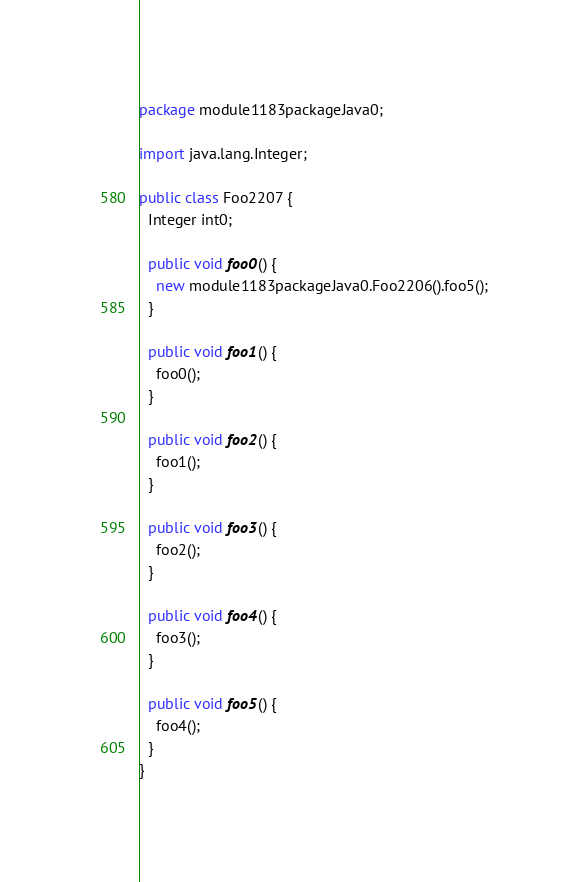<code> <loc_0><loc_0><loc_500><loc_500><_Java_>package module1183packageJava0;

import java.lang.Integer;

public class Foo2207 {
  Integer int0;

  public void foo0() {
    new module1183packageJava0.Foo2206().foo5();
  }

  public void foo1() {
    foo0();
  }

  public void foo2() {
    foo1();
  }

  public void foo3() {
    foo2();
  }

  public void foo4() {
    foo3();
  }

  public void foo5() {
    foo4();
  }
}
</code> 